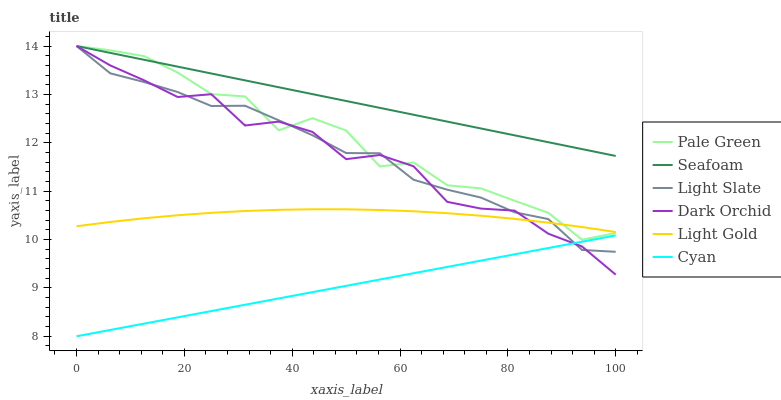Does Cyan have the minimum area under the curve?
Answer yes or no. Yes. Does Seafoam have the maximum area under the curve?
Answer yes or no. Yes. Does Dark Orchid have the minimum area under the curve?
Answer yes or no. No. Does Dark Orchid have the maximum area under the curve?
Answer yes or no. No. Is Seafoam the smoothest?
Answer yes or no. Yes. Is Pale Green the roughest?
Answer yes or no. Yes. Is Dark Orchid the smoothest?
Answer yes or no. No. Is Dark Orchid the roughest?
Answer yes or no. No. Does Cyan have the lowest value?
Answer yes or no. Yes. Does Dark Orchid have the lowest value?
Answer yes or no. No. Does Pale Green have the highest value?
Answer yes or no. Yes. Does Cyan have the highest value?
Answer yes or no. No. Is Cyan less than Pale Green?
Answer yes or no. Yes. Is Seafoam greater than Cyan?
Answer yes or no. Yes. Does Light Gold intersect Dark Orchid?
Answer yes or no. Yes. Is Light Gold less than Dark Orchid?
Answer yes or no. No. Is Light Gold greater than Dark Orchid?
Answer yes or no. No. Does Cyan intersect Pale Green?
Answer yes or no. No. 